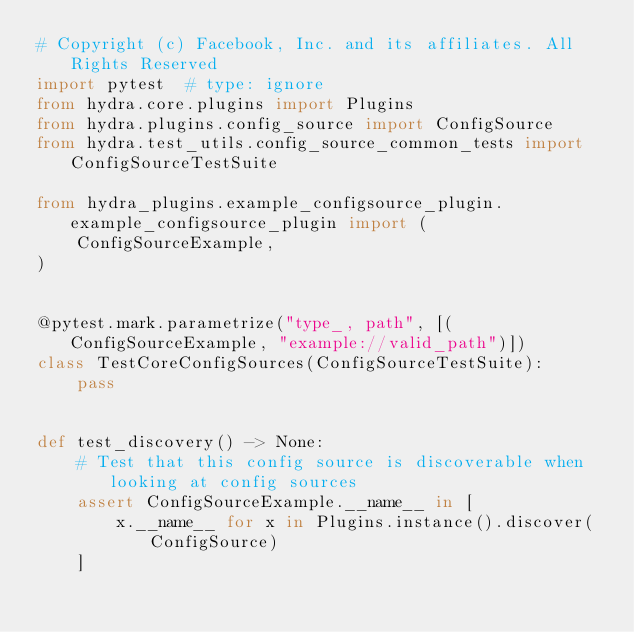Convert code to text. <code><loc_0><loc_0><loc_500><loc_500><_Python_># Copyright (c) Facebook, Inc. and its affiliates. All Rights Reserved
import pytest  # type: ignore
from hydra.core.plugins import Plugins
from hydra.plugins.config_source import ConfigSource
from hydra.test_utils.config_source_common_tests import ConfigSourceTestSuite

from hydra_plugins.example_configsource_plugin.example_configsource_plugin import (
    ConfigSourceExample,
)


@pytest.mark.parametrize("type_, path", [(ConfigSourceExample, "example://valid_path")])
class TestCoreConfigSources(ConfigSourceTestSuite):
    pass


def test_discovery() -> None:
    # Test that this config source is discoverable when looking at config sources
    assert ConfigSourceExample.__name__ in [
        x.__name__ for x in Plugins.instance().discover(ConfigSource)
    ]
</code> 